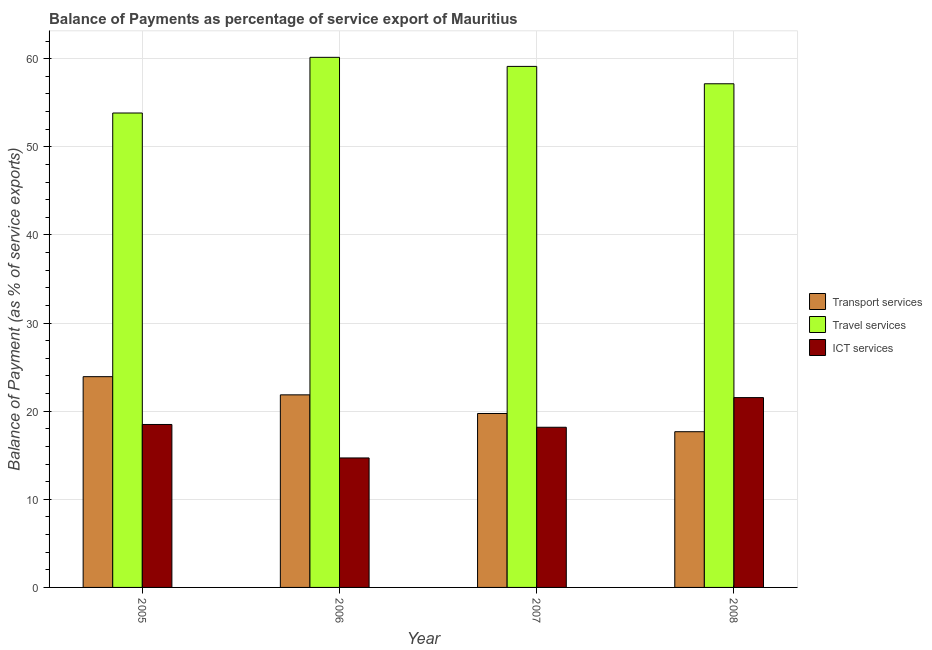How many different coloured bars are there?
Give a very brief answer. 3. Are the number of bars per tick equal to the number of legend labels?
Your answer should be compact. Yes. What is the balance of payment of ict services in 2005?
Give a very brief answer. 18.49. Across all years, what is the maximum balance of payment of ict services?
Offer a terse response. 21.54. Across all years, what is the minimum balance of payment of transport services?
Keep it short and to the point. 17.67. In which year was the balance of payment of transport services maximum?
Give a very brief answer. 2005. What is the total balance of payment of travel services in the graph?
Your response must be concise. 230.25. What is the difference between the balance of payment of transport services in 2006 and that in 2007?
Ensure brevity in your answer.  2.12. What is the difference between the balance of payment of travel services in 2006 and the balance of payment of transport services in 2005?
Make the answer very short. 6.32. What is the average balance of payment of transport services per year?
Your answer should be compact. 20.79. In the year 2007, what is the difference between the balance of payment of ict services and balance of payment of travel services?
Ensure brevity in your answer.  0. In how many years, is the balance of payment of travel services greater than 14 %?
Offer a very short reply. 4. What is the ratio of the balance of payment of ict services in 2005 to that in 2008?
Your answer should be very brief. 0.86. What is the difference between the highest and the second highest balance of payment of ict services?
Your answer should be compact. 3.05. What is the difference between the highest and the lowest balance of payment of travel services?
Ensure brevity in your answer.  6.32. In how many years, is the balance of payment of travel services greater than the average balance of payment of travel services taken over all years?
Ensure brevity in your answer.  2. Is the sum of the balance of payment of ict services in 2005 and 2006 greater than the maximum balance of payment of transport services across all years?
Provide a short and direct response. Yes. What does the 2nd bar from the left in 2007 represents?
Keep it short and to the point. Travel services. What does the 2nd bar from the right in 2006 represents?
Your answer should be very brief. Travel services. Is it the case that in every year, the sum of the balance of payment of transport services and balance of payment of travel services is greater than the balance of payment of ict services?
Provide a short and direct response. Yes. Are all the bars in the graph horizontal?
Ensure brevity in your answer.  No. How many years are there in the graph?
Your answer should be very brief. 4. What is the difference between two consecutive major ticks on the Y-axis?
Give a very brief answer. 10. Does the graph contain grids?
Your response must be concise. Yes. How are the legend labels stacked?
Keep it short and to the point. Vertical. What is the title of the graph?
Your answer should be very brief. Balance of Payments as percentage of service export of Mauritius. What is the label or title of the X-axis?
Offer a very short reply. Year. What is the label or title of the Y-axis?
Offer a terse response. Balance of Payment (as % of service exports). What is the Balance of Payment (as % of service exports) in Transport services in 2005?
Your answer should be compact. 23.92. What is the Balance of Payment (as % of service exports) in Travel services in 2005?
Provide a succinct answer. 53.83. What is the Balance of Payment (as % of service exports) in ICT services in 2005?
Provide a short and direct response. 18.49. What is the Balance of Payment (as % of service exports) of Transport services in 2006?
Offer a terse response. 21.85. What is the Balance of Payment (as % of service exports) in Travel services in 2006?
Ensure brevity in your answer.  60.15. What is the Balance of Payment (as % of service exports) in ICT services in 2006?
Make the answer very short. 14.69. What is the Balance of Payment (as % of service exports) of Transport services in 2007?
Offer a terse response. 19.74. What is the Balance of Payment (as % of service exports) in Travel services in 2007?
Offer a very short reply. 59.12. What is the Balance of Payment (as % of service exports) of ICT services in 2007?
Ensure brevity in your answer.  18.17. What is the Balance of Payment (as % of service exports) of Transport services in 2008?
Your answer should be very brief. 17.67. What is the Balance of Payment (as % of service exports) of Travel services in 2008?
Make the answer very short. 57.15. What is the Balance of Payment (as % of service exports) in ICT services in 2008?
Offer a very short reply. 21.54. Across all years, what is the maximum Balance of Payment (as % of service exports) of Transport services?
Ensure brevity in your answer.  23.92. Across all years, what is the maximum Balance of Payment (as % of service exports) of Travel services?
Offer a terse response. 60.15. Across all years, what is the maximum Balance of Payment (as % of service exports) of ICT services?
Your answer should be very brief. 21.54. Across all years, what is the minimum Balance of Payment (as % of service exports) in Transport services?
Your answer should be very brief. 17.67. Across all years, what is the minimum Balance of Payment (as % of service exports) in Travel services?
Your answer should be very brief. 53.83. Across all years, what is the minimum Balance of Payment (as % of service exports) in ICT services?
Provide a succinct answer. 14.69. What is the total Balance of Payment (as % of service exports) in Transport services in the graph?
Offer a very short reply. 83.17. What is the total Balance of Payment (as % of service exports) in Travel services in the graph?
Provide a short and direct response. 230.25. What is the total Balance of Payment (as % of service exports) in ICT services in the graph?
Keep it short and to the point. 72.89. What is the difference between the Balance of Payment (as % of service exports) in Transport services in 2005 and that in 2006?
Provide a short and direct response. 2.06. What is the difference between the Balance of Payment (as % of service exports) in Travel services in 2005 and that in 2006?
Offer a very short reply. -6.32. What is the difference between the Balance of Payment (as % of service exports) in ICT services in 2005 and that in 2006?
Provide a succinct answer. 3.8. What is the difference between the Balance of Payment (as % of service exports) in Transport services in 2005 and that in 2007?
Provide a succinct answer. 4.18. What is the difference between the Balance of Payment (as % of service exports) of Travel services in 2005 and that in 2007?
Ensure brevity in your answer.  -5.29. What is the difference between the Balance of Payment (as % of service exports) of ICT services in 2005 and that in 2007?
Ensure brevity in your answer.  0.32. What is the difference between the Balance of Payment (as % of service exports) in Transport services in 2005 and that in 2008?
Ensure brevity in your answer.  6.25. What is the difference between the Balance of Payment (as % of service exports) in Travel services in 2005 and that in 2008?
Your answer should be compact. -3.32. What is the difference between the Balance of Payment (as % of service exports) in ICT services in 2005 and that in 2008?
Your answer should be compact. -3.05. What is the difference between the Balance of Payment (as % of service exports) of Transport services in 2006 and that in 2007?
Your response must be concise. 2.12. What is the difference between the Balance of Payment (as % of service exports) in Travel services in 2006 and that in 2007?
Make the answer very short. 1.03. What is the difference between the Balance of Payment (as % of service exports) in ICT services in 2006 and that in 2007?
Give a very brief answer. -3.48. What is the difference between the Balance of Payment (as % of service exports) in Transport services in 2006 and that in 2008?
Keep it short and to the point. 4.18. What is the difference between the Balance of Payment (as % of service exports) in Travel services in 2006 and that in 2008?
Make the answer very short. 3. What is the difference between the Balance of Payment (as % of service exports) in ICT services in 2006 and that in 2008?
Give a very brief answer. -6.85. What is the difference between the Balance of Payment (as % of service exports) of Transport services in 2007 and that in 2008?
Ensure brevity in your answer.  2.07. What is the difference between the Balance of Payment (as % of service exports) in Travel services in 2007 and that in 2008?
Offer a very short reply. 1.97. What is the difference between the Balance of Payment (as % of service exports) in ICT services in 2007 and that in 2008?
Ensure brevity in your answer.  -3.37. What is the difference between the Balance of Payment (as % of service exports) of Transport services in 2005 and the Balance of Payment (as % of service exports) of Travel services in 2006?
Ensure brevity in your answer.  -36.23. What is the difference between the Balance of Payment (as % of service exports) of Transport services in 2005 and the Balance of Payment (as % of service exports) of ICT services in 2006?
Provide a short and direct response. 9.22. What is the difference between the Balance of Payment (as % of service exports) in Travel services in 2005 and the Balance of Payment (as % of service exports) in ICT services in 2006?
Provide a short and direct response. 39.14. What is the difference between the Balance of Payment (as % of service exports) of Transport services in 2005 and the Balance of Payment (as % of service exports) of Travel services in 2007?
Your answer should be very brief. -35.2. What is the difference between the Balance of Payment (as % of service exports) in Transport services in 2005 and the Balance of Payment (as % of service exports) in ICT services in 2007?
Provide a succinct answer. 5.74. What is the difference between the Balance of Payment (as % of service exports) of Travel services in 2005 and the Balance of Payment (as % of service exports) of ICT services in 2007?
Ensure brevity in your answer.  35.66. What is the difference between the Balance of Payment (as % of service exports) of Transport services in 2005 and the Balance of Payment (as % of service exports) of Travel services in 2008?
Ensure brevity in your answer.  -33.23. What is the difference between the Balance of Payment (as % of service exports) of Transport services in 2005 and the Balance of Payment (as % of service exports) of ICT services in 2008?
Your answer should be compact. 2.38. What is the difference between the Balance of Payment (as % of service exports) in Travel services in 2005 and the Balance of Payment (as % of service exports) in ICT services in 2008?
Ensure brevity in your answer.  32.29. What is the difference between the Balance of Payment (as % of service exports) in Transport services in 2006 and the Balance of Payment (as % of service exports) in Travel services in 2007?
Keep it short and to the point. -37.27. What is the difference between the Balance of Payment (as % of service exports) of Transport services in 2006 and the Balance of Payment (as % of service exports) of ICT services in 2007?
Offer a very short reply. 3.68. What is the difference between the Balance of Payment (as % of service exports) in Travel services in 2006 and the Balance of Payment (as % of service exports) in ICT services in 2007?
Ensure brevity in your answer.  41.97. What is the difference between the Balance of Payment (as % of service exports) in Transport services in 2006 and the Balance of Payment (as % of service exports) in Travel services in 2008?
Give a very brief answer. -35.3. What is the difference between the Balance of Payment (as % of service exports) of Transport services in 2006 and the Balance of Payment (as % of service exports) of ICT services in 2008?
Provide a succinct answer. 0.31. What is the difference between the Balance of Payment (as % of service exports) in Travel services in 2006 and the Balance of Payment (as % of service exports) in ICT services in 2008?
Make the answer very short. 38.61. What is the difference between the Balance of Payment (as % of service exports) of Transport services in 2007 and the Balance of Payment (as % of service exports) of Travel services in 2008?
Provide a succinct answer. -37.41. What is the difference between the Balance of Payment (as % of service exports) of Transport services in 2007 and the Balance of Payment (as % of service exports) of ICT services in 2008?
Offer a terse response. -1.8. What is the difference between the Balance of Payment (as % of service exports) of Travel services in 2007 and the Balance of Payment (as % of service exports) of ICT services in 2008?
Offer a terse response. 37.58. What is the average Balance of Payment (as % of service exports) of Transport services per year?
Make the answer very short. 20.79. What is the average Balance of Payment (as % of service exports) of Travel services per year?
Offer a terse response. 57.56. What is the average Balance of Payment (as % of service exports) in ICT services per year?
Offer a very short reply. 18.22. In the year 2005, what is the difference between the Balance of Payment (as % of service exports) in Transport services and Balance of Payment (as % of service exports) in Travel services?
Your response must be concise. -29.92. In the year 2005, what is the difference between the Balance of Payment (as % of service exports) of Transport services and Balance of Payment (as % of service exports) of ICT services?
Give a very brief answer. 5.43. In the year 2005, what is the difference between the Balance of Payment (as % of service exports) of Travel services and Balance of Payment (as % of service exports) of ICT services?
Provide a succinct answer. 35.34. In the year 2006, what is the difference between the Balance of Payment (as % of service exports) of Transport services and Balance of Payment (as % of service exports) of Travel services?
Ensure brevity in your answer.  -38.3. In the year 2006, what is the difference between the Balance of Payment (as % of service exports) of Transport services and Balance of Payment (as % of service exports) of ICT services?
Your answer should be compact. 7.16. In the year 2006, what is the difference between the Balance of Payment (as % of service exports) of Travel services and Balance of Payment (as % of service exports) of ICT services?
Your response must be concise. 45.46. In the year 2007, what is the difference between the Balance of Payment (as % of service exports) in Transport services and Balance of Payment (as % of service exports) in Travel services?
Your response must be concise. -39.38. In the year 2007, what is the difference between the Balance of Payment (as % of service exports) of Transport services and Balance of Payment (as % of service exports) of ICT services?
Your answer should be compact. 1.56. In the year 2007, what is the difference between the Balance of Payment (as % of service exports) of Travel services and Balance of Payment (as % of service exports) of ICT services?
Provide a succinct answer. 40.95. In the year 2008, what is the difference between the Balance of Payment (as % of service exports) in Transport services and Balance of Payment (as % of service exports) in Travel services?
Ensure brevity in your answer.  -39.48. In the year 2008, what is the difference between the Balance of Payment (as % of service exports) of Transport services and Balance of Payment (as % of service exports) of ICT services?
Give a very brief answer. -3.87. In the year 2008, what is the difference between the Balance of Payment (as % of service exports) of Travel services and Balance of Payment (as % of service exports) of ICT services?
Make the answer very short. 35.61. What is the ratio of the Balance of Payment (as % of service exports) of Transport services in 2005 to that in 2006?
Provide a succinct answer. 1.09. What is the ratio of the Balance of Payment (as % of service exports) in Travel services in 2005 to that in 2006?
Make the answer very short. 0.9. What is the ratio of the Balance of Payment (as % of service exports) in ICT services in 2005 to that in 2006?
Give a very brief answer. 1.26. What is the ratio of the Balance of Payment (as % of service exports) in Transport services in 2005 to that in 2007?
Provide a succinct answer. 1.21. What is the ratio of the Balance of Payment (as % of service exports) of Travel services in 2005 to that in 2007?
Provide a short and direct response. 0.91. What is the ratio of the Balance of Payment (as % of service exports) of ICT services in 2005 to that in 2007?
Provide a short and direct response. 1.02. What is the ratio of the Balance of Payment (as % of service exports) in Transport services in 2005 to that in 2008?
Your response must be concise. 1.35. What is the ratio of the Balance of Payment (as % of service exports) in Travel services in 2005 to that in 2008?
Provide a succinct answer. 0.94. What is the ratio of the Balance of Payment (as % of service exports) in ICT services in 2005 to that in 2008?
Make the answer very short. 0.86. What is the ratio of the Balance of Payment (as % of service exports) of Transport services in 2006 to that in 2007?
Keep it short and to the point. 1.11. What is the ratio of the Balance of Payment (as % of service exports) of Travel services in 2006 to that in 2007?
Offer a terse response. 1.02. What is the ratio of the Balance of Payment (as % of service exports) in ICT services in 2006 to that in 2007?
Give a very brief answer. 0.81. What is the ratio of the Balance of Payment (as % of service exports) of Transport services in 2006 to that in 2008?
Keep it short and to the point. 1.24. What is the ratio of the Balance of Payment (as % of service exports) of Travel services in 2006 to that in 2008?
Provide a succinct answer. 1.05. What is the ratio of the Balance of Payment (as % of service exports) of ICT services in 2006 to that in 2008?
Offer a very short reply. 0.68. What is the ratio of the Balance of Payment (as % of service exports) in Transport services in 2007 to that in 2008?
Give a very brief answer. 1.12. What is the ratio of the Balance of Payment (as % of service exports) of Travel services in 2007 to that in 2008?
Your response must be concise. 1.03. What is the ratio of the Balance of Payment (as % of service exports) of ICT services in 2007 to that in 2008?
Offer a very short reply. 0.84. What is the difference between the highest and the second highest Balance of Payment (as % of service exports) of Transport services?
Make the answer very short. 2.06. What is the difference between the highest and the second highest Balance of Payment (as % of service exports) in Travel services?
Ensure brevity in your answer.  1.03. What is the difference between the highest and the second highest Balance of Payment (as % of service exports) in ICT services?
Offer a very short reply. 3.05. What is the difference between the highest and the lowest Balance of Payment (as % of service exports) in Transport services?
Your response must be concise. 6.25. What is the difference between the highest and the lowest Balance of Payment (as % of service exports) in Travel services?
Provide a succinct answer. 6.32. What is the difference between the highest and the lowest Balance of Payment (as % of service exports) of ICT services?
Your response must be concise. 6.85. 